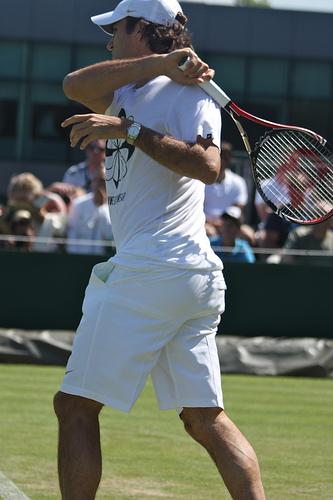What are some details about the tennis court and the area surrounding it? The tennis court has grass, a gray tarp on the ground, a fence, a wall in front of the crowd, and people watching the event. How would you describe the main subject's appearance in this image? The main subject is a man wearing a white hat, white shirt and shorts, with long brown hair under the hat, playing a game of tennis. Can you give a brief account of the spectators present in the image? There is a crowd of people watching the tennis game, including a person wearing a blue shirt. Please provide a brief description of the tennis player's attire. The tennis player is wearing a white hat with a swoosh logo, a white t-shirt with a black design, white shorts, and a gold watch. Describe any visible logos or brand names on items within the image. There is a swoosh logo on the man's hat, which is the Nike logo, and a 'W' logo on the tennis racquet, representing the Wilson brand. Identify the primary activity taking place in the image and the person involved. A man is playing tennis, holding a racquet in his hand. What brand is the logo on the hat of the person playing tennis? The logo on the hat is Nike. What is the color of the man's watch, and where is it located? The man's watch is gold and is located on his wrist. Examine the tennis racquet closely and describe its distinctive features. The tennis racquet has a red and black frame, wires, a handle, and a 'W' logo on it. Notice the purple umbrella being held by a woman in the crowd. No, it's not mentioned in the image. Identify the color and brand of the hat worn by the tennis player. The hat color is white and the brand is Nike. What is the color of the tennis court? The tennis court is grass green. Determine the location of the swoosh logo. The swoosh logo is located on the hat. Name a key detail about the appearance of the man playing tennis. The man has long brown hair that is visible under his white hat. Characterize the design on the man's shirt. The design is black. What kind of watch is on the man's wrist? It is a gold watch. Estimate the sentiment of the image. The image sentiment is neutral, as it is just depicting a sports event. List the objects in the image related to the tennis racquet. handle, wires, red and black frame, W on the racket, Wilson racquet. What are the people standing behind the fence doing? They are watching the event. What are the colors of the tennis racquet's frame and the logo on the hat? The racquet's frame is red and black, and the logo on the hat is black. Which object shows the athlete holding the tennis racquet? his hand Point to where the man is holding the tennis racket. The racket is being held at X:170 Y:50 Width:56 Height:56. Answer the following questions about the image: What is the athlete wearing on his head? What is the color of his shorts? The athlete is wearing a white hat on his head and his shorts are white. How would you rate the image quality, considering the level of detail, contrast and color balance? The image quality is good, considering detailed visibility of scene, adequate contrast and appropriate color balance. Segment the image by identifying all the key objects within the bounds of their respective coordinates. Man playing tennis (X: 47 Y: 0 Width: 280 Height: 280), his white hat (X: 85 Y: 0 Width: 113 Height: 113), Nike logo (X: 122 Y: 7 Width: 15 Height: 15), white shorts (X: 54 Y: 250 Width: 178 Height: 178), tennis racket (X: 170 Y: 49 Width: 161 Height: 161), gold watch (X: 122 Y: 118 Width: 19 Height: 19). In the image, are there any visible writings or text? No visible writings or text. Is the man wearing a white hat, if yes, note the dimensions? Yes, he is wearing a white hat with dimensions X:85 Y:0 Width:113 Height:113. Describe the scene in the image. A man is playing tennis on a grass court, wearing a white hat, white shorts and holding a racquet. A crowd of people are watching the match from behind a fence. Search for a stray tennis ball behind the player. As per the given image information, there is no mention of a tennis ball anywhere. This instruction might mislead the reader into thinking that there is a ball present in the image that they need to find. Does the tennis player have any visible tattoos or body markings? No visible tattoos, but there is a visible vein on his calf muscle. 